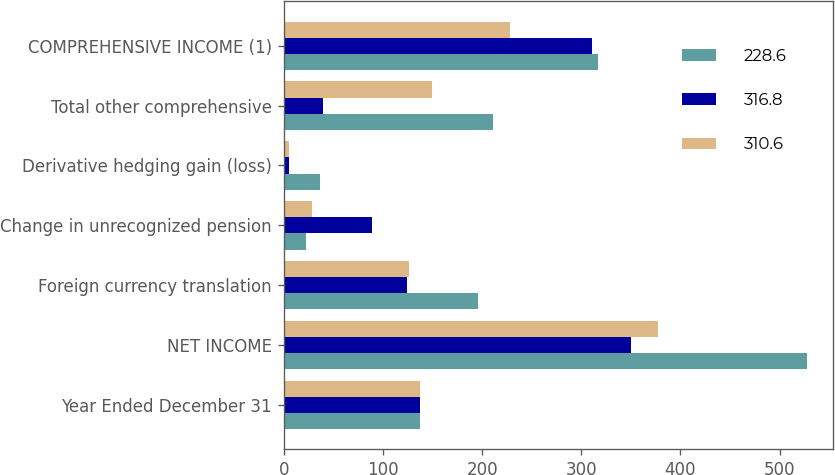<chart> <loc_0><loc_0><loc_500><loc_500><stacked_bar_chart><ecel><fcel>Year Ended December 31<fcel>NET INCOME<fcel>Foreign currency translation<fcel>Change in unrecognized pension<fcel>Derivative hedging gain (loss)<fcel>Total other comprehensive<fcel>COMPREHENSIVE INCOME (1)<nl><fcel>228.6<fcel>137.75<fcel>527.8<fcel>196.2<fcel>22.3<fcel>37.1<fcel>211<fcel>316.8<nl><fcel>316.8<fcel>137.75<fcel>350<fcel>123.9<fcel>89.4<fcel>4.9<fcel>39.4<fcel>310.6<nl><fcel>310.6<fcel>137.75<fcel>377.8<fcel>126.3<fcel>28.4<fcel>5.5<fcel>149.2<fcel>228.6<nl></chart> 